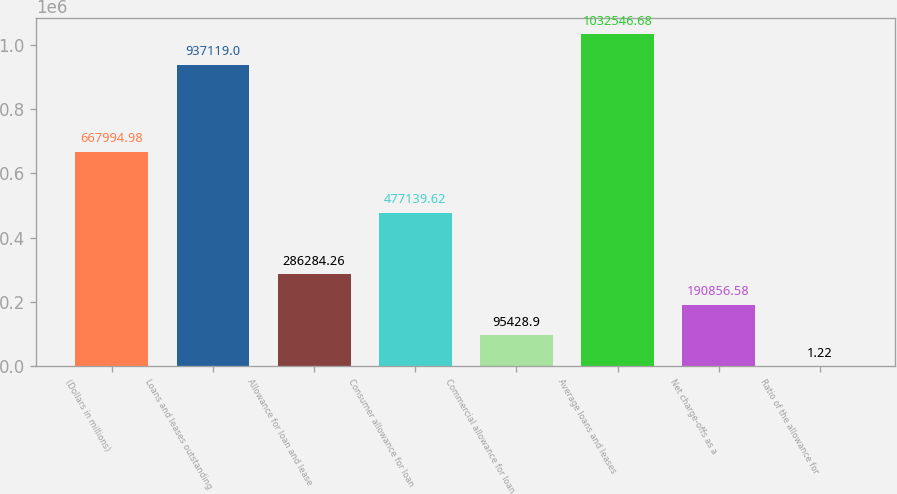<chart> <loc_0><loc_0><loc_500><loc_500><bar_chart><fcel>(Dollars in millions)<fcel>Loans and leases outstanding<fcel>Allowance for loan and lease<fcel>Consumer allowance for loan<fcel>Commercial allowance for loan<fcel>Average loans and leases<fcel>Net charge-offs as a<fcel>Ratio of the allowance for<nl><fcel>667995<fcel>937119<fcel>286284<fcel>477140<fcel>95428.9<fcel>1.03255e+06<fcel>190857<fcel>1.22<nl></chart> 